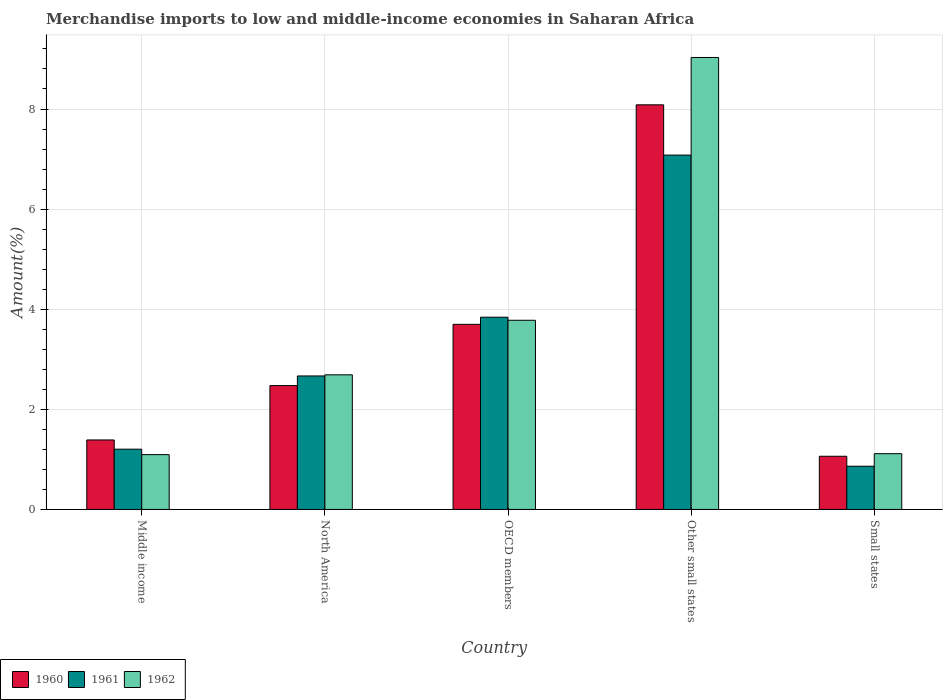How many groups of bars are there?
Keep it short and to the point. 5. Are the number of bars on each tick of the X-axis equal?
Make the answer very short. Yes. How many bars are there on the 3rd tick from the left?
Provide a succinct answer. 3. What is the label of the 1st group of bars from the left?
Offer a terse response. Middle income. What is the percentage of amount earned from merchandise imports in 1960 in Middle income?
Give a very brief answer. 1.39. Across all countries, what is the maximum percentage of amount earned from merchandise imports in 1961?
Offer a terse response. 7.08. Across all countries, what is the minimum percentage of amount earned from merchandise imports in 1960?
Keep it short and to the point. 1.06. In which country was the percentage of amount earned from merchandise imports in 1961 maximum?
Your answer should be very brief. Other small states. What is the total percentage of amount earned from merchandise imports in 1961 in the graph?
Provide a short and direct response. 15.66. What is the difference between the percentage of amount earned from merchandise imports in 1961 in North America and that in Small states?
Offer a very short reply. 1.8. What is the difference between the percentage of amount earned from merchandise imports in 1961 in OECD members and the percentage of amount earned from merchandise imports in 1960 in Middle income?
Your answer should be very brief. 2.45. What is the average percentage of amount earned from merchandise imports in 1961 per country?
Ensure brevity in your answer.  3.13. What is the difference between the percentage of amount earned from merchandise imports of/in 1961 and percentage of amount earned from merchandise imports of/in 1960 in Small states?
Give a very brief answer. -0.2. In how many countries, is the percentage of amount earned from merchandise imports in 1960 greater than 5.2 %?
Keep it short and to the point. 1. What is the ratio of the percentage of amount earned from merchandise imports in 1961 in Middle income to that in OECD members?
Provide a short and direct response. 0.31. Is the difference between the percentage of amount earned from merchandise imports in 1961 in OECD members and Small states greater than the difference between the percentage of amount earned from merchandise imports in 1960 in OECD members and Small states?
Your answer should be very brief. Yes. What is the difference between the highest and the second highest percentage of amount earned from merchandise imports in 1962?
Ensure brevity in your answer.  6.34. What is the difference between the highest and the lowest percentage of amount earned from merchandise imports in 1961?
Keep it short and to the point. 6.22. Is the sum of the percentage of amount earned from merchandise imports in 1961 in Middle income and OECD members greater than the maximum percentage of amount earned from merchandise imports in 1960 across all countries?
Keep it short and to the point. No. Is it the case that in every country, the sum of the percentage of amount earned from merchandise imports in 1960 and percentage of amount earned from merchandise imports in 1961 is greater than the percentage of amount earned from merchandise imports in 1962?
Keep it short and to the point. Yes. How many countries are there in the graph?
Your answer should be very brief. 5. Are the values on the major ticks of Y-axis written in scientific E-notation?
Ensure brevity in your answer.  No. How many legend labels are there?
Offer a very short reply. 3. How are the legend labels stacked?
Make the answer very short. Horizontal. What is the title of the graph?
Your answer should be very brief. Merchandise imports to low and middle-income economies in Saharan Africa. What is the label or title of the Y-axis?
Make the answer very short. Amount(%). What is the Amount(%) of 1960 in Middle income?
Give a very brief answer. 1.39. What is the Amount(%) in 1961 in Middle income?
Offer a very short reply. 1.2. What is the Amount(%) in 1962 in Middle income?
Keep it short and to the point. 1.1. What is the Amount(%) of 1960 in North America?
Offer a terse response. 2.47. What is the Amount(%) of 1961 in North America?
Offer a very short reply. 2.67. What is the Amount(%) in 1962 in North America?
Ensure brevity in your answer.  2.69. What is the Amount(%) of 1960 in OECD members?
Provide a succinct answer. 3.7. What is the Amount(%) in 1961 in OECD members?
Your response must be concise. 3.84. What is the Amount(%) of 1962 in OECD members?
Your answer should be very brief. 3.78. What is the Amount(%) in 1960 in Other small states?
Give a very brief answer. 8.08. What is the Amount(%) in 1961 in Other small states?
Your response must be concise. 7.08. What is the Amount(%) of 1962 in Other small states?
Ensure brevity in your answer.  9.03. What is the Amount(%) of 1960 in Small states?
Your answer should be compact. 1.06. What is the Amount(%) of 1961 in Small states?
Your answer should be very brief. 0.86. What is the Amount(%) of 1962 in Small states?
Provide a succinct answer. 1.11. Across all countries, what is the maximum Amount(%) of 1960?
Your response must be concise. 8.08. Across all countries, what is the maximum Amount(%) of 1961?
Offer a very short reply. 7.08. Across all countries, what is the maximum Amount(%) in 1962?
Your answer should be very brief. 9.03. Across all countries, what is the minimum Amount(%) in 1960?
Provide a succinct answer. 1.06. Across all countries, what is the minimum Amount(%) in 1961?
Keep it short and to the point. 0.86. Across all countries, what is the minimum Amount(%) in 1962?
Your response must be concise. 1.1. What is the total Amount(%) of 1960 in the graph?
Make the answer very short. 16.71. What is the total Amount(%) in 1961 in the graph?
Ensure brevity in your answer.  15.66. What is the total Amount(%) in 1962 in the graph?
Your answer should be very brief. 17.71. What is the difference between the Amount(%) of 1960 in Middle income and that in North America?
Your response must be concise. -1.09. What is the difference between the Amount(%) in 1961 in Middle income and that in North America?
Keep it short and to the point. -1.46. What is the difference between the Amount(%) in 1962 in Middle income and that in North America?
Your response must be concise. -1.59. What is the difference between the Amount(%) of 1960 in Middle income and that in OECD members?
Offer a very short reply. -2.31. What is the difference between the Amount(%) in 1961 in Middle income and that in OECD members?
Your answer should be very brief. -2.64. What is the difference between the Amount(%) of 1962 in Middle income and that in OECD members?
Provide a succinct answer. -2.68. What is the difference between the Amount(%) of 1960 in Middle income and that in Other small states?
Offer a terse response. -6.7. What is the difference between the Amount(%) of 1961 in Middle income and that in Other small states?
Your answer should be compact. -5.88. What is the difference between the Amount(%) in 1962 in Middle income and that in Other small states?
Your answer should be very brief. -7.93. What is the difference between the Amount(%) in 1960 in Middle income and that in Small states?
Offer a terse response. 0.33. What is the difference between the Amount(%) of 1961 in Middle income and that in Small states?
Keep it short and to the point. 0.34. What is the difference between the Amount(%) in 1962 in Middle income and that in Small states?
Your answer should be compact. -0.02. What is the difference between the Amount(%) of 1960 in North America and that in OECD members?
Your answer should be very brief. -1.22. What is the difference between the Amount(%) in 1961 in North America and that in OECD members?
Provide a short and direct response. -1.17. What is the difference between the Amount(%) in 1962 in North America and that in OECD members?
Ensure brevity in your answer.  -1.09. What is the difference between the Amount(%) in 1960 in North America and that in Other small states?
Offer a very short reply. -5.61. What is the difference between the Amount(%) in 1961 in North America and that in Other small states?
Your answer should be compact. -4.41. What is the difference between the Amount(%) of 1962 in North America and that in Other small states?
Your response must be concise. -6.34. What is the difference between the Amount(%) of 1960 in North America and that in Small states?
Provide a succinct answer. 1.41. What is the difference between the Amount(%) of 1961 in North America and that in Small states?
Give a very brief answer. 1.8. What is the difference between the Amount(%) of 1962 in North America and that in Small states?
Your answer should be very brief. 1.58. What is the difference between the Amount(%) in 1960 in OECD members and that in Other small states?
Offer a terse response. -4.39. What is the difference between the Amount(%) in 1961 in OECD members and that in Other small states?
Make the answer very short. -3.24. What is the difference between the Amount(%) in 1962 in OECD members and that in Other small states?
Provide a short and direct response. -5.25. What is the difference between the Amount(%) in 1960 in OECD members and that in Small states?
Make the answer very short. 2.64. What is the difference between the Amount(%) in 1961 in OECD members and that in Small states?
Your response must be concise. 2.98. What is the difference between the Amount(%) of 1962 in OECD members and that in Small states?
Offer a very short reply. 2.67. What is the difference between the Amount(%) in 1960 in Other small states and that in Small states?
Your answer should be very brief. 7.02. What is the difference between the Amount(%) in 1961 in Other small states and that in Small states?
Your answer should be very brief. 6.22. What is the difference between the Amount(%) of 1962 in Other small states and that in Small states?
Your response must be concise. 7.92. What is the difference between the Amount(%) of 1960 in Middle income and the Amount(%) of 1961 in North America?
Keep it short and to the point. -1.28. What is the difference between the Amount(%) of 1960 in Middle income and the Amount(%) of 1962 in North America?
Your response must be concise. -1.3. What is the difference between the Amount(%) of 1961 in Middle income and the Amount(%) of 1962 in North America?
Give a very brief answer. -1.49. What is the difference between the Amount(%) of 1960 in Middle income and the Amount(%) of 1961 in OECD members?
Ensure brevity in your answer.  -2.45. What is the difference between the Amount(%) of 1960 in Middle income and the Amount(%) of 1962 in OECD members?
Make the answer very short. -2.39. What is the difference between the Amount(%) of 1961 in Middle income and the Amount(%) of 1962 in OECD members?
Give a very brief answer. -2.58. What is the difference between the Amount(%) of 1960 in Middle income and the Amount(%) of 1961 in Other small states?
Your answer should be very brief. -5.69. What is the difference between the Amount(%) in 1960 in Middle income and the Amount(%) in 1962 in Other small states?
Give a very brief answer. -7.64. What is the difference between the Amount(%) in 1961 in Middle income and the Amount(%) in 1962 in Other small states?
Give a very brief answer. -7.83. What is the difference between the Amount(%) in 1960 in Middle income and the Amount(%) in 1961 in Small states?
Ensure brevity in your answer.  0.52. What is the difference between the Amount(%) in 1960 in Middle income and the Amount(%) in 1962 in Small states?
Make the answer very short. 0.27. What is the difference between the Amount(%) of 1961 in Middle income and the Amount(%) of 1962 in Small states?
Provide a short and direct response. 0.09. What is the difference between the Amount(%) of 1960 in North America and the Amount(%) of 1961 in OECD members?
Your answer should be very brief. -1.37. What is the difference between the Amount(%) in 1960 in North America and the Amount(%) in 1962 in OECD members?
Your answer should be compact. -1.3. What is the difference between the Amount(%) of 1961 in North America and the Amount(%) of 1962 in OECD members?
Give a very brief answer. -1.11. What is the difference between the Amount(%) of 1960 in North America and the Amount(%) of 1961 in Other small states?
Provide a short and direct response. -4.6. What is the difference between the Amount(%) in 1960 in North America and the Amount(%) in 1962 in Other small states?
Make the answer very short. -6.55. What is the difference between the Amount(%) in 1961 in North America and the Amount(%) in 1962 in Other small states?
Make the answer very short. -6.36. What is the difference between the Amount(%) of 1960 in North America and the Amount(%) of 1961 in Small states?
Make the answer very short. 1.61. What is the difference between the Amount(%) of 1960 in North America and the Amount(%) of 1962 in Small states?
Give a very brief answer. 1.36. What is the difference between the Amount(%) of 1961 in North America and the Amount(%) of 1962 in Small states?
Your answer should be compact. 1.55. What is the difference between the Amount(%) in 1960 in OECD members and the Amount(%) in 1961 in Other small states?
Offer a terse response. -3.38. What is the difference between the Amount(%) of 1960 in OECD members and the Amount(%) of 1962 in Other small states?
Provide a short and direct response. -5.33. What is the difference between the Amount(%) of 1961 in OECD members and the Amount(%) of 1962 in Other small states?
Ensure brevity in your answer.  -5.19. What is the difference between the Amount(%) in 1960 in OECD members and the Amount(%) in 1961 in Small states?
Provide a short and direct response. 2.83. What is the difference between the Amount(%) of 1960 in OECD members and the Amount(%) of 1962 in Small states?
Offer a very short reply. 2.58. What is the difference between the Amount(%) of 1961 in OECD members and the Amount(%) of 1962 in Small states?
Your answer should be very brief. 2.73. What is the difference between the Amount(%) of 1960 in Other small states and the Amount(%) of 1961 in Small states?
Your answer should be compact. 7.22. What is the difference between the Amount(%) in 1960 in Other small states and the Amount(%) in 1962 in Small states?
Offer a terse response. 6.97. What is the difference between the Amount(%) in 1961 in Other small states and the Amount(%) in 1962 in Small states?
Give a very brief answer. 5.97. What is the average Amount(%) in 1960 per country?
Give a very brief answer. 3.34. What is the average Amount(%) of 1961 per country?
Keep it short and to the point. 3.13. What is the average Amount(%) of 1962 per country?
Offer a very short reply. 3.54. What is the difference between the Amount(%) in 1960 and Amount(%) in 1961 in Middle income?
Offer a terse response. 0.18. What is the difference between the Amount(%) in 1960 and Amount(%) in 1962 in Middle income?
Your answer should be compact. 0.29. What is the difference between the Amount(%) of 1961 and Amount(%) of 1962 in Middle income?
Make the answer very short. 0.11. What is the difference between the Amount(%) in 1960 and Amount(%) in 1961 in North America?
Give a very brief answer. -0.19. What is the difference between the Amount(%) in 1960 and Amount(%) in 1962 in North America?
Your answer should be compact. -0.21. What is the difference between the Amount(%) in 1961 and Amount(%) in 1962 in North America?
Your answer should be very brief. -0.02. What is the difference between the Amount(%) in 1960 and Amount(%) in 1961 in OECD members?
Offer a terse response. -0.14. What is the difference between the Amount(%) of 1960 and Amount(%) of 1962 in OECD members?
Offer a terse response. -0.08. What is the difference between the Amount(%) of 1961 and Amount(%) of 1962 in OECD members?
Make the answer very short. 0.06. What is the difference between the Amount(%) in 1960 and Amount(%) in 1962 in Other small states?
Provide a short and direct response. -0.95. What is the difference between the Amount(%) in 1961 and Amount(%) in 1962 in Other small states?
Make the answer very short. -1.95. What is the difference between the Amount(%) in 1960 and Amount(%) in 1961 in Small states?
Offer a very short reply. 0.2. What is the difference between the Amount(%) in 1960 and Amount(%) in 1962 in Small states?
Offer a very short reply. -0.05. What is the difference between the Amount(%) of 1961 and Amount(%) of 1962 in Small states?
Keep it short and to the point. -0.25. What is the ratio of the Amount(%) of 1960 in Middle income to that in North America?
Your answer should be very brief. 0.56. What is the ratio of the Amount(%) in 1961 in Middle income to that in North America?
Make the answer very short. 0.45. What is the ratio of the Amount(%) in 1962 in Middle income to that in North America?
Your response must be concise. 0.41. What is the ratio of the Amount(%) in 1960 in Middle income to that in OECD members?
Provide a short and direct response. 0.38. What is the ratio of the Amount(%) of 1961 in Middle income to that in OECD members?
Your answer should be compact. 0.31. What is the ratio of the Amount(%) in 1962 in Middle income to that in OECD members?
Keep it short and to the point. 0.29. What is the ratio of the Amount(%) of 1960 in Middle income to that in Other small states?
Provide a succinct answer. 0.17. What is the ratio of the Amount(%) of 1961 in Middle income to that in Other small states?
Offer a very short reply. 0.17. What is the ratio of the Amount(%) of 1962 in Middle income to that in Other small states?
Keep it short and to the point. 0.12. What is the ratio of the Amount(%) of 1960 in Middle income to that in Small states?
Keep it short and to the point. 1.31. What is the ratio of the Amount(%) in 1961 in Middle income to that in Small states?
Your answer should be compact. 1.39. What is the ratio of the Amount(%) in 1962 in Middle income to that in Small states?
Your answer should be compact. 0.98. What is the ratio of the Amount(%) in 1960 in North America to that in OECD members?
Ensure brevity in your answer.  0.67. What is the ratio of the Amount(%) of 1961 in North America to that in OECD members?
Give a very brief answer. 0.69. What is the ratio of the Amount(%) of 1962 in North America to that in OECD members?
Give a very brief answer. 0.71. What is the ratio of the Amount(%) of 1960 in North America to that in Other small states?
Your answer should be very brief. 0.31. What is the ratio of the Amount(%) in 1961 in North America to that in Other small states?
Provide a succinct answer. 0.38. What is the ratio of the Amount(%) of 1962 in North America to that in Other small states?
Provide a succinct answer. 0.3. What is the ratio of the Amount(%) of 1960 in North America to that in Small states?
Offer a terse response. 2.33. What is the ratio of the Amount(%) in 1961 in North America to that in Small states?
Make the answer very short. 3.09. What is the ratio of the Amount(%) of 1962 in North America to that in Small states?
Give a very brief answer. 2.41. What is the ratio of the Amount(%) of 1960 in OECD members to that in Other small states?
Ensure brevity in your answer.  0.46. What is the ratio of the Amount(%) in 1961 in OECD members to that in Other small states?
Offer a terse response. 0.54. What is the ratio of the Amount(%) of 1962 in OECD members to that in Other small states?
Keep it short and to the point. 0.42. What is the ratio of the Amount(%) in 1960 in OECD members to that in Small states?
Ensure brevity in your answer.  3.48. What is the ratio of the Amount(%) of 1961 in OECD members to that in Small states?
Provide a short and direct response. 4.45. What is the ratio of the Amount(%) in 1962 in OECD members to that in Small states?
Give a very brief answer. 3.39. What is the ratio of the Amount(%) of 1960 in Other small states to that in Small states?
Give a very brief answer. 7.61. What is the ratio of the Amount(%) of 1961 in Other small states to that in Small states?
Provide a short and direct response. 8.2. What is the ratio of the Amount(%) of 1962 in Other small states to that in Small states?
Provide a succinct answer. 8.1. What is the difference between the highest and the second highest Amount(%) in 1960?
Offer a terse response. 4.39. What is the difference between the highest and the second highest Amount(%) in 1961?
Ensure brevity in your answer.  3.24. What is the difference between the highest and the second highest Amount(%) of 1962?
Provide a succinct answer. 5.25. What is the difference between the highest and the lowest Amount(%) of 1960?
Your answer should be compact. 7.02. What is the difference between the highest and the lowest Amount(%) in 1961?
Keep it short and to the point. 6.22. What is the difference between the highest and the lowest Amount(%) of 1962?
Your answer should be compact. 7.93. 